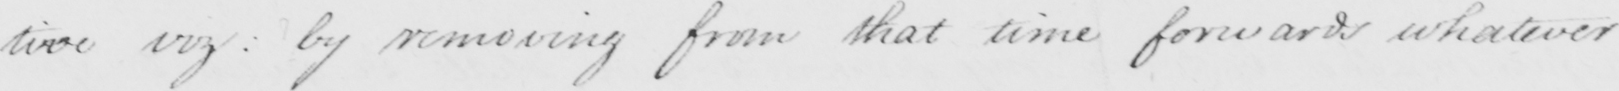Transcribe the text shown in this historical manuscript line. viz: by removing from that time forwards whatever 